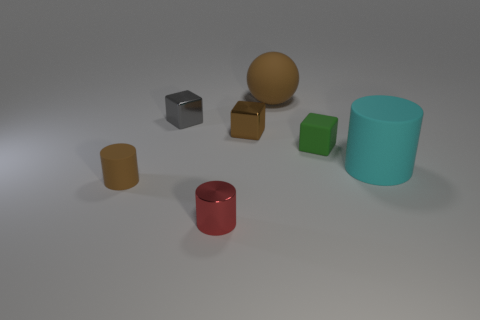Subtract all shiny cylinders. How many cylinders are left? 2 Add 1 matte spheres. How many objects exist? 8 Subtract 3 cylinders. How many cylinders are left? 0 Subtract all red cylinders. How many cylinders are left? 2 Subtract all blocks. How many objects are left? 4 Subtract all gray balls. Subtract all green cylinders. How many balls are left? 1 Subtract all brown blocks. How many green cylinders are left? 0 Subtract all spheres. Subtract all tiny cubes. How many objects are left? 3 Add 3 large matte cylinders. How many large matte cylinders are left? 4 Add 7 green matte things. How many green matte things exist? 8 